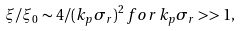<formula> <loc_0><loc_0><loc_500><loc_500>\xi / \xi _ { 0 } \sim 4 / ( k _ { p } \sigma _ { r } ) ^ { 2 } \, f o r \, k _ { p } \sigma _ { r } > > 1 ,</formula> 